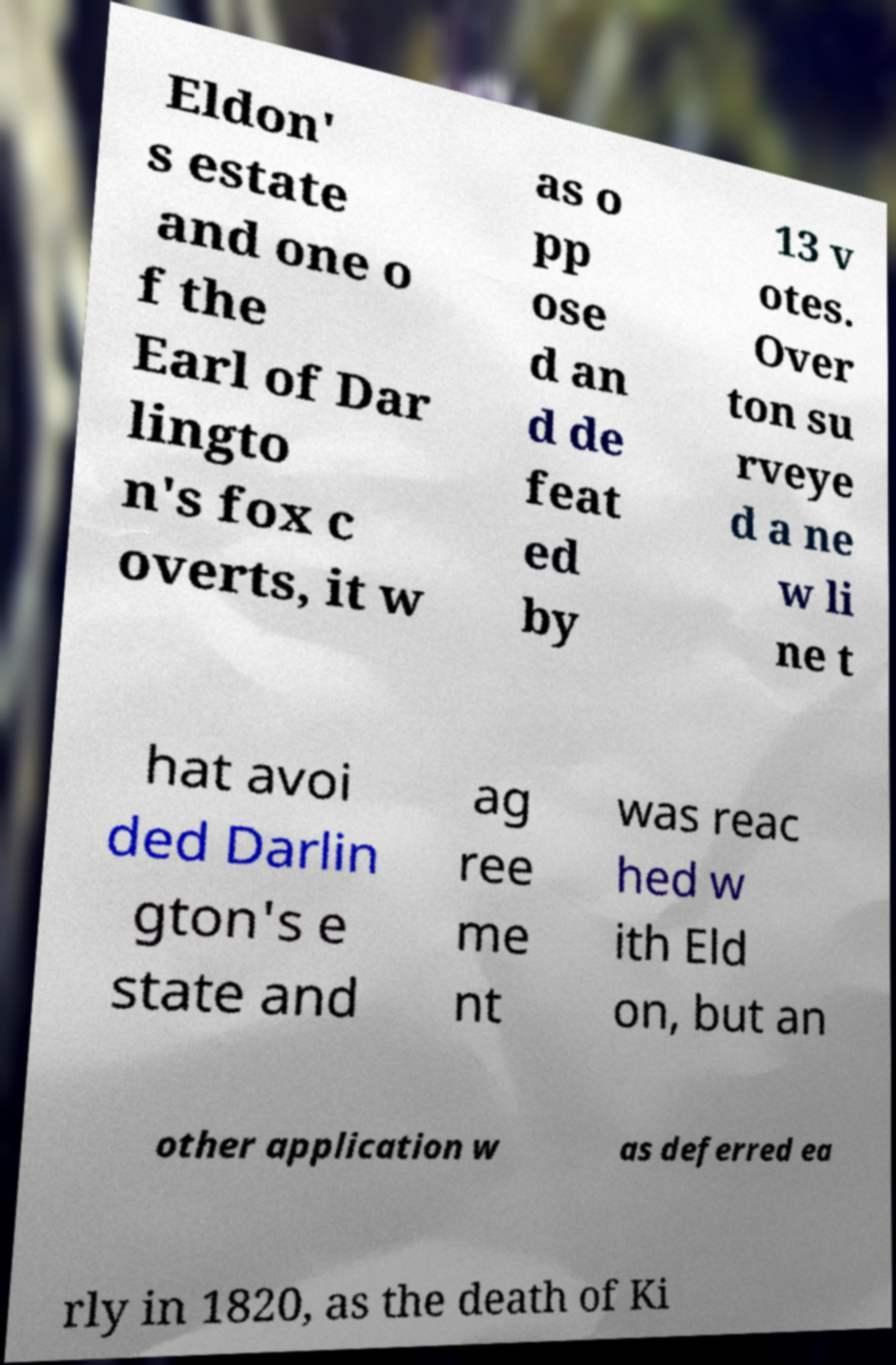Could you extract and type out the text from this image? Eldon' s estate and one o f the Earl of Dar lingto n's fox c overts, it w as o pp ose d an d de feat ed by 13 v otes. Over ton su rveye d a ne w li ne t hat avoi ded Darlin gton's e state and ag ree me nt was reac hed w ith Eld on, but an other application w as deferred ea rly in 1820, as the death of Ki 